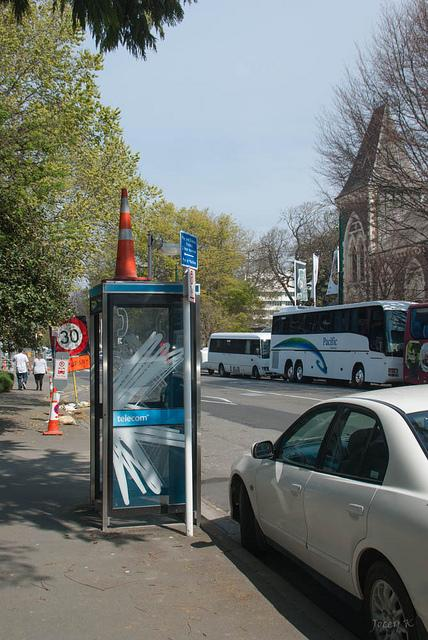Originally what was the glass booth designed for? phone booth 